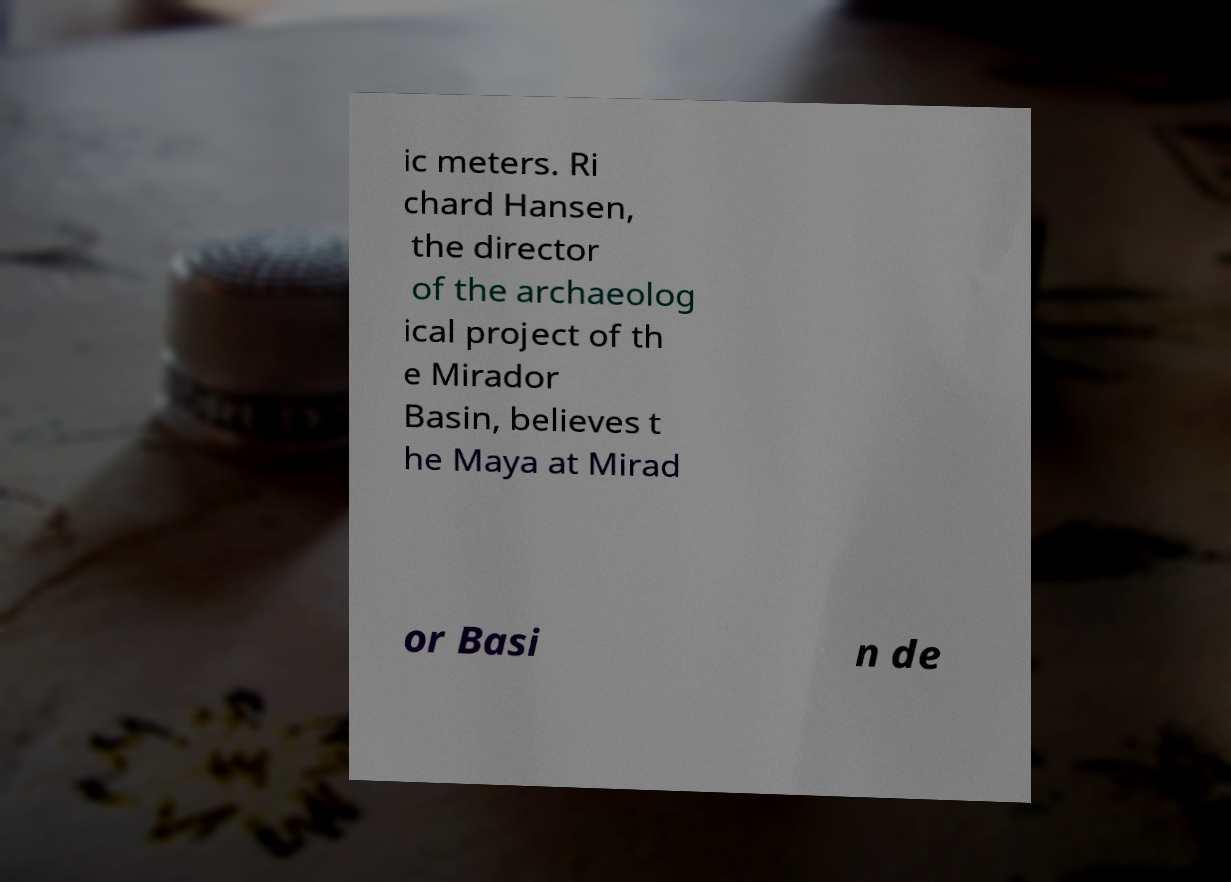For documentation purposes, I need the text within this image transcribed. Could you provide that? ic meters. Ri chard Hansen, the director of the archaeolog ical project of th e Mirador Basin, believes t he Maya at Mirad or Basi n de 